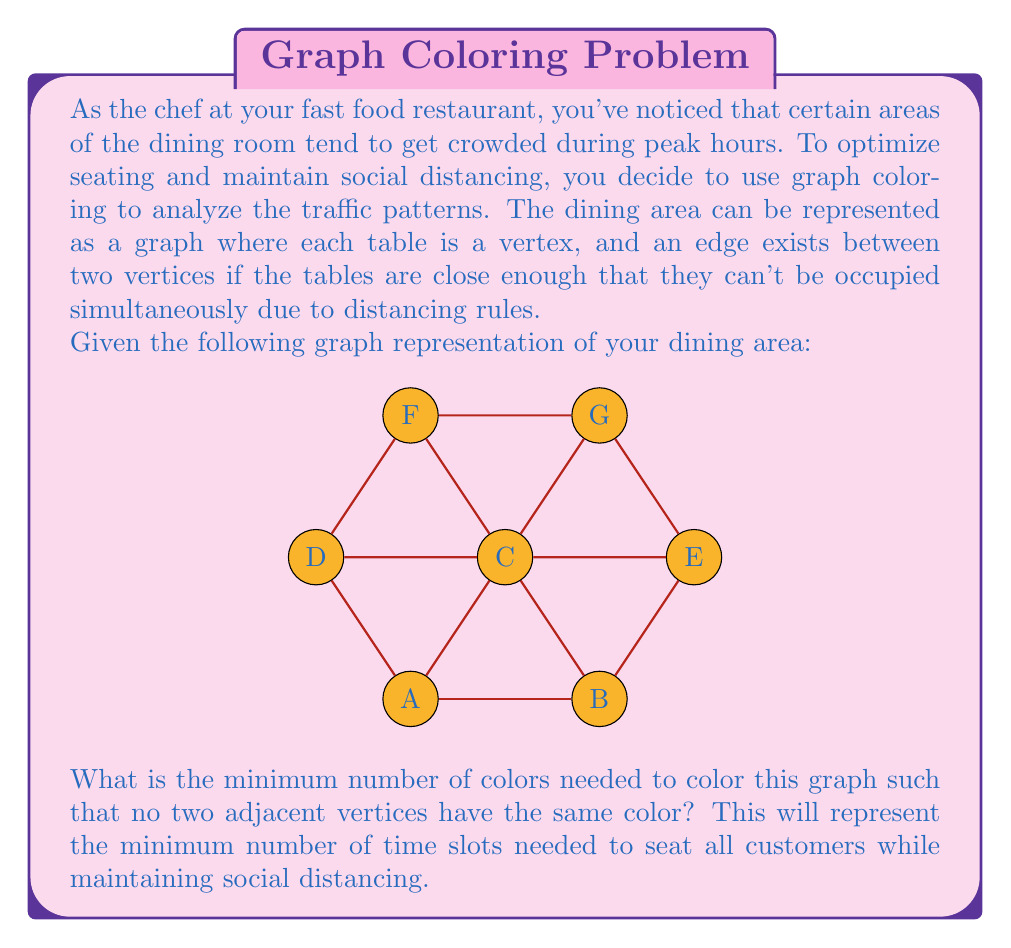Show me your answer to this math problem. To solve this problem, we need to find the chromatic number of the given graph. The chromatic number is the minimum number of colors needed to color a graph such that no two adjacent vertices have the same color. Let's approach this step-by-step:

1) First, let's analyze the graph:
   - It has 7 vertices (A, B, C, D, E, F, G)
   - The maximum degree (number of edges connected to a vertex) is 5 (vertex C)

2) A useful theorem states that the chromatic number is always less than or equal to the maximum degree plus one. So, we know that the chromatic number is at most 6.

3) Let's try to color the graph with fewer colors:

   Step 1: Color vertex C with color 1. All its neighbors must have different colors.
   Step 2: Color A with 2, B with 3, D with 3, E with 4, F with 4.
   Step 3: The only vertex left is G. It's adjacent to C (color 1), E (color 4), and F (color 4).
   Step 4: We can color G with color 2 or 3.

4) After this process, we've successfully colored the graph using 4 colors:
   - Color 1: C
   - Color 2: A, G
   - Color 3: B, D
   - Color 4: E, F

5) We can verify that no two adjacent vertices have the same color.

6) It's not possible to color this graph with fewer than 4 colors because vertex C has 5 neighbors, and at least 3 of them must have different colors from C and each other.

Therefore, the chromatic number of this graph is 4.
Answer: The minimum number of colors needed to color this graph is 4. This means the restaurant needs at least 4 different time slots to seat all customers while maintaining social distancing. 